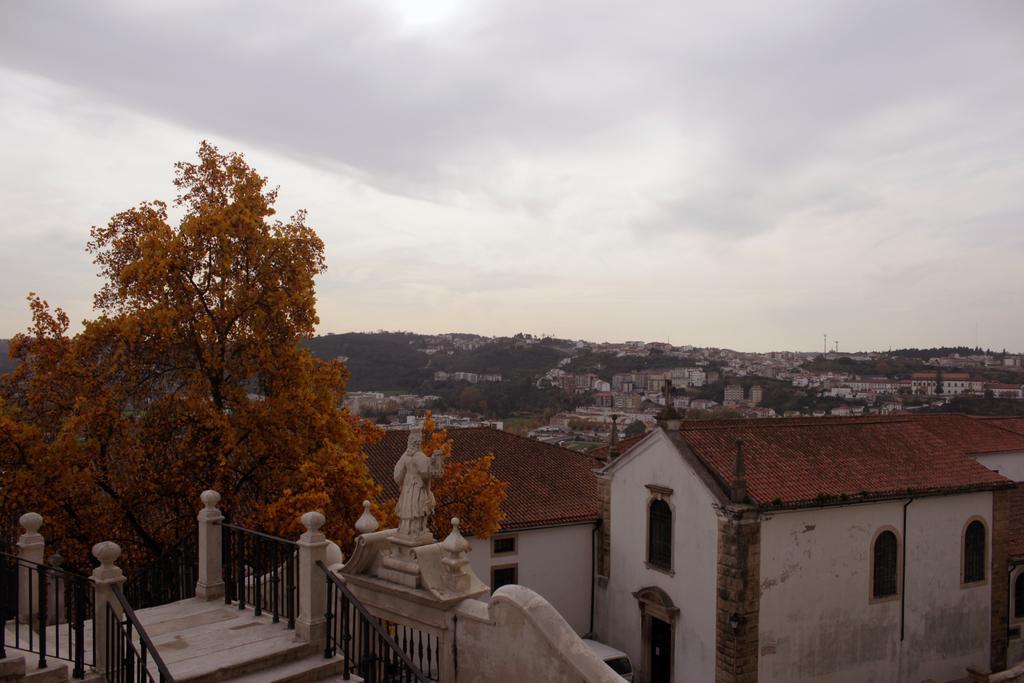Could you give a brief overview of what you see in this image? In this picture I can see some some buildings, sculptures, staircases with fencing and also I can see some trees. 